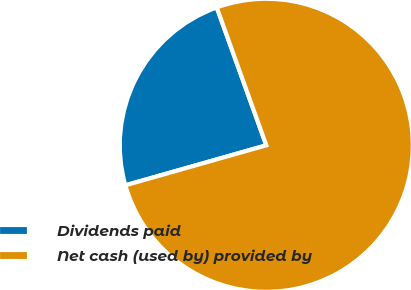Convert chart. <chart><loc_0><loc_0><loc_500><loc_500><pie_chart><fcel>Dividends paid<fcel>Net cash (used by) provided by<nl><fcel>23.91%<fcel>76.09%<nl></chart> 